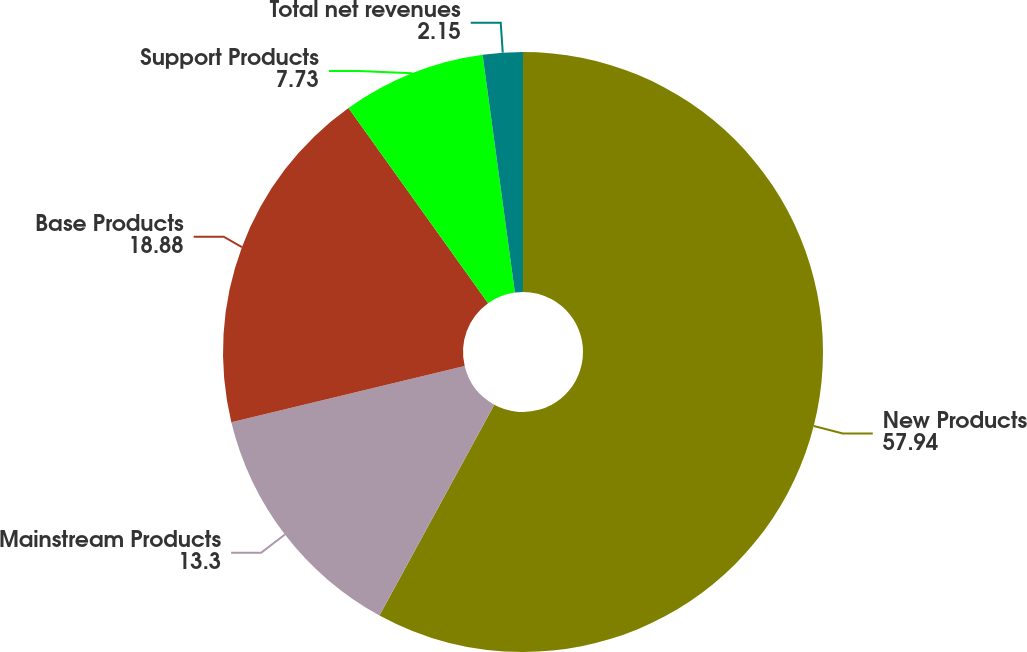Convert chart to OTSL. <chart><loc_0><loc_0><loc_500><loc_500><pie_chart><fcel>New Products<fcel>Mainstream Products<fcel>Base Products<fcel>Support Products<fcel>Total net revenues<nl><fcel>57.94%<fcel>13.3%<fcel>18.88%<fcel>7.73%<fcel>2.15%<nl></chart> 